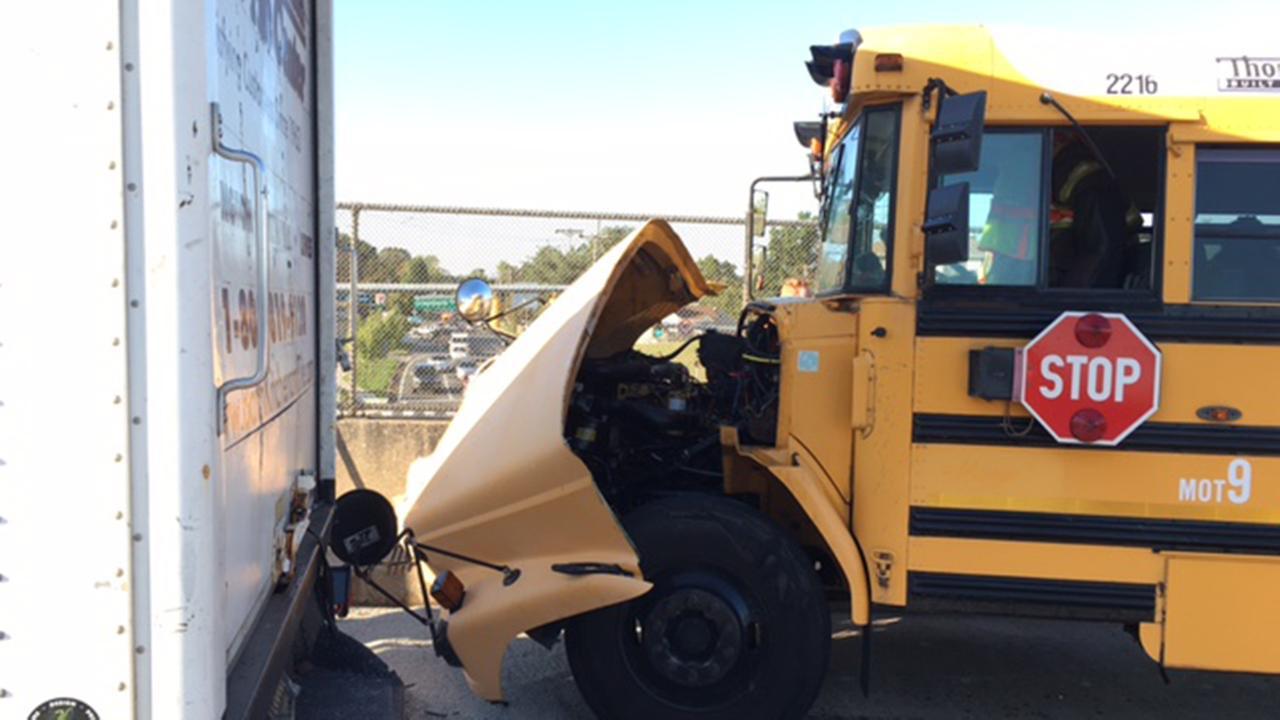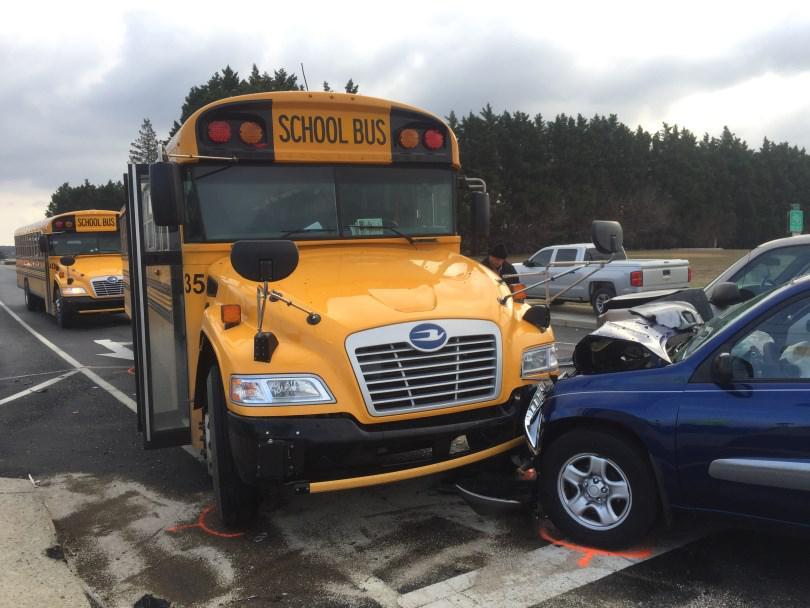The first image is the image on the left, the second image is the image on the right. Examine the images to the left and right. Is the description "In one of the images you can see firemen tending to an accident between a school bus and a white truck." accurate? Answer yes or no. No. The first image is the image on the left, the second image is the image on the right. Analyze the images presented: Is the assertion "A white truck is visible in the left image." valid? Answer yes or no. No. 